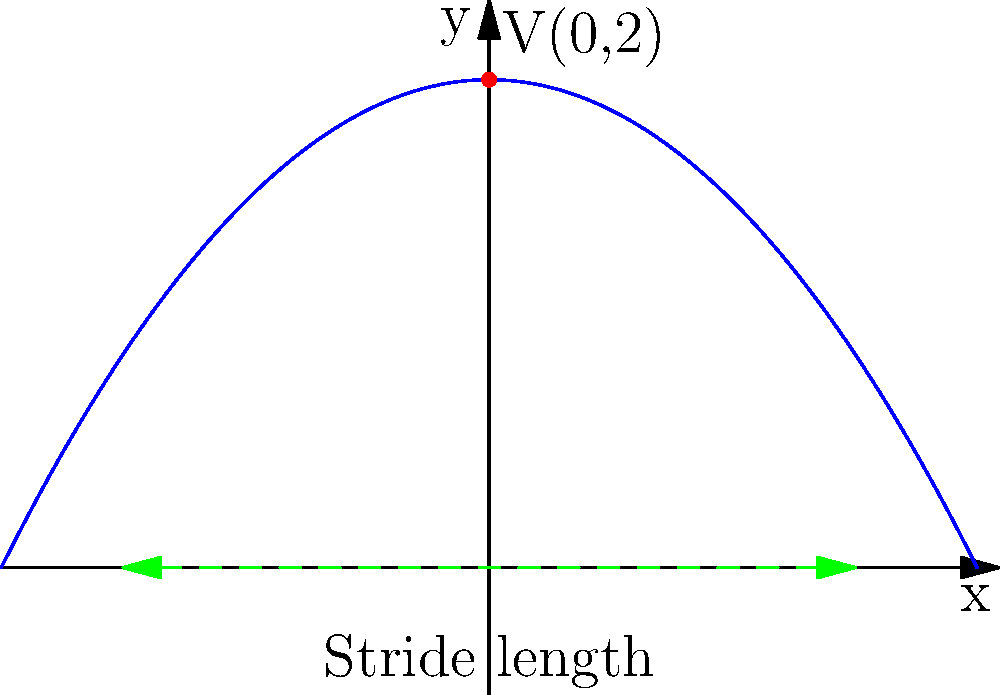In the parabolic path of a runner's center of mass during a stride, represented by the equation $y = -0.5x^2 + 2$, what is the maximum height reached, and how does this relate to the conservation of energy principle in physics? To solve this problem, we'll follow these steps:

1) The parabola representing the runner's center of mass is given by the equation:
   $y = -0.5x^2 + 2$

2) This is in the form $y = a(x-h)^2 + k$, where $(h,k)$ is the vertex of the parabola.

3) Comparing our equation to this form:
   $y = -0.5(x-0)^2 + 2$

4) We can see that the vertex is at $(0,2)$. This point represents the maximum height of the parabola.

5) Therefore, the maximum height reached is 2 units.

6) This relates to the conservation of energy principle in physics as follows:
   - At the start and end of the stride, the runner's energy is mostly kinetic.
   - As the runner's center of mass rises, kinetic energy is converted to potential energy.
   - At the vertex (highest point), the potential energy is at its maximum, and the vertical component of velocity is momentarily zero.
   - This is analogous to the motion of a projectile or a simple harmonic oscillator.

7) The parabolic shape itself is a result of the constant acceleration due to gravity, similar to projectile motion in physics.

8) The symmetry of the parabola reflects the conservation of energy: energy converted from kinetic to potential on the way up is fully converted back from potential to kinetic on the way down (assuming no energy loss).
Answer: Maximum height: 2 units. Relates to energy conservation: KE converts to PE at apex, then back to KE, mirroring projectile motion. 